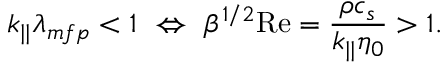Convert formula to latex. <formula><loc_0><loc_0><loc_500><loc_500>k _ { | | } \lambda _ { m f p } < 1 \ \Leftrightarrow \ \beta ^ { 1 / 2 } R e = \frac { \rho c _ { s } } { k _ { | | } \eta _ { 0 } } > 1 .</formula> 